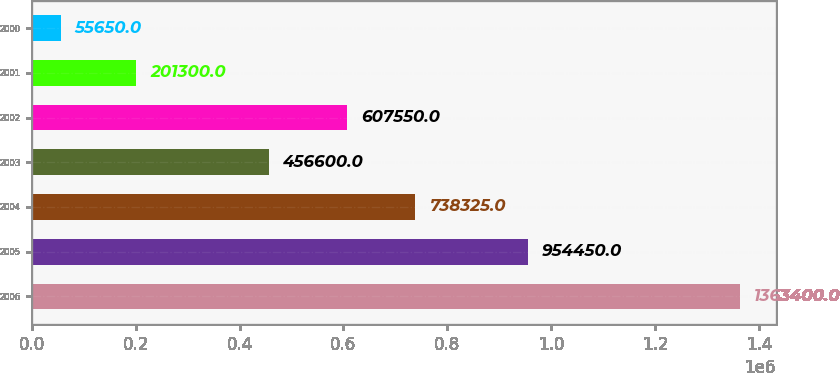Convert chart. <chart><loc_0><loc_0><loc_500><loc_500><bar_chart><fcel>2006<fcel>2005<fcel>2004<fcel>2003<fcel>2002<fcel>2001<fcel>2000<nl><fcel>1.3634e+06<fcel>954450<fcel>738325<fcel>456600<fcel>607550<fcel>201300<fcel>55650<nl></chart> 